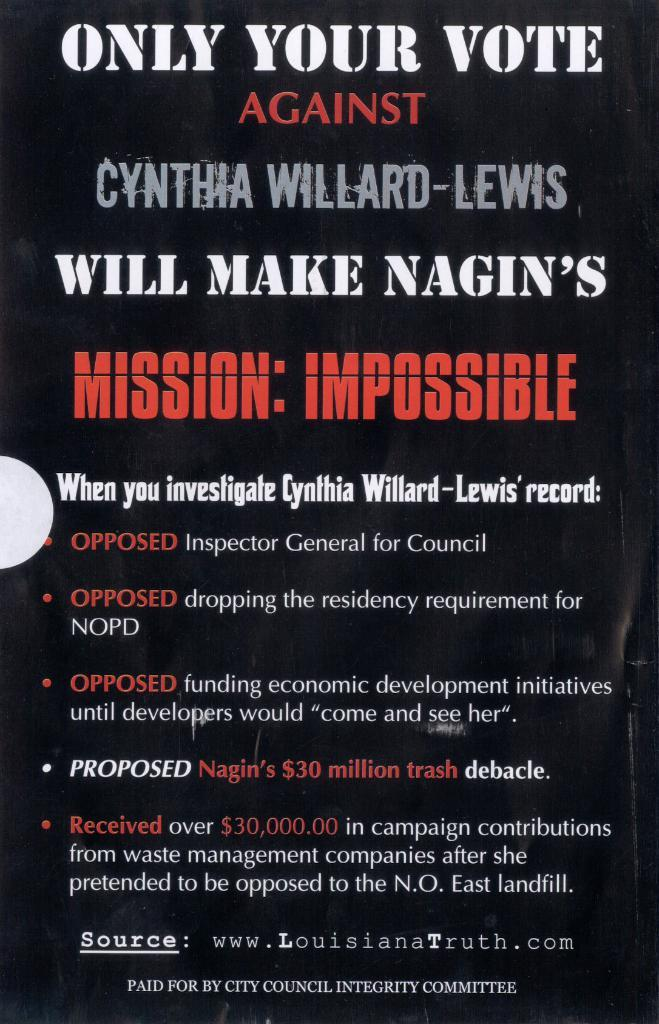Provide a one-sentence caption for the provided image. A sign by Louisiana Truth about Cynthia Willard-Lewis. 